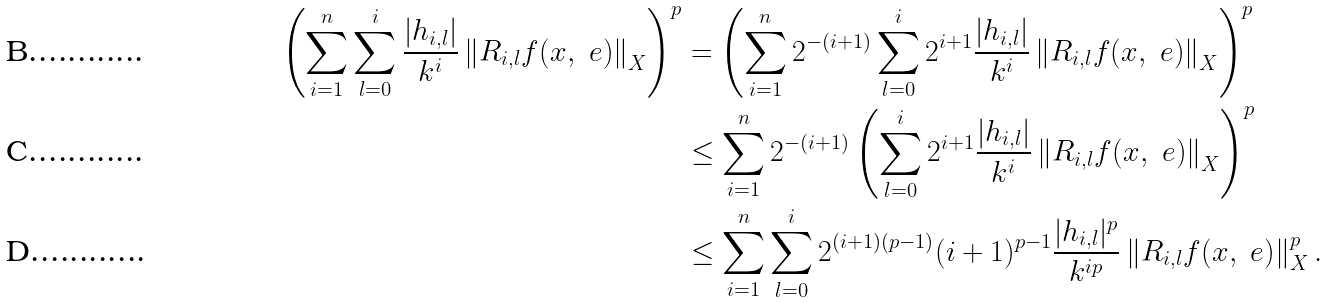Convert formula to latex. <formula><loc_0><loc_0><loc_500><loc_500>\left ( { \sum _ { i = 1 } ^ { n } \sum _ { l = 0 } ^ { i } \frac { | h _ { i , l } | } { k ^ { i } } \left \| { R _ { i , l } f ( x , \ e ) } \right \| _ { X } } \right ) ^ { p } & = \left ( { \sum _ { i = 1 } ^ { n } 2 ^ { - ( i + 1 ) } \sum _ { l = 0 } ^ { i } 2 ^ { i + 1 } \frac { | h _ { i , l } | } { k ^ { i } } \left \| { R _ { i , l } f ( x , \ e ) } \right \| _ { X } } \right ) ^ { p } \\ & \leq \sum _ { i = 1 } ^ { n } 2 ^ { - ( i + 1 ) } \left ( { \sum _ { l = 0 } ^ { i } 2 ^ { i + 1 } \frac { | h _ { i , l } | } { k ^ { i } } \left \| { R _ { i , l } f ( x , \ e ) } \right \| _ { X } } \right ) ^ { p } \\ & \leq \sum _ { i = 1 } ^ { n } \sum _ { l = 0 } ^ { i } 2 ^ { ( i + 1 ) ( p - 1 ) } ( i + 1 ) ^ { p - 1 } \frac { | h _ { i , l } | ^ { p } } { k ^ { i p } } \left \| { R _ { i , l } f ( x , \ e ) } \right \| _ { X } ^ { p } .</formula> 